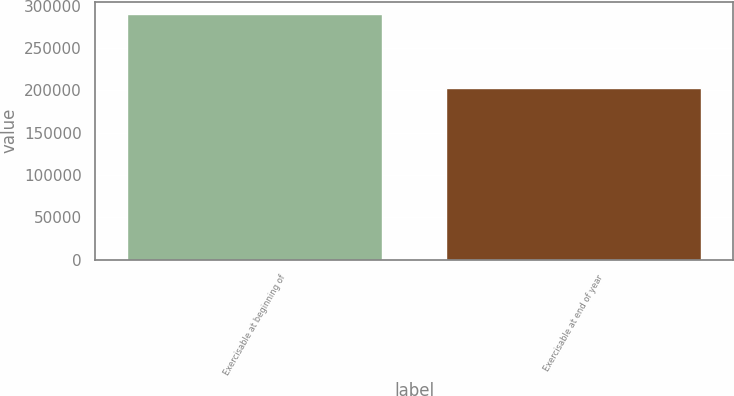<chart> <loc_0><loc_0><loc_500><loc_500><bar_chart><fcel>Exercisable at beginning of<fcel>Exercisable at end of year<nl><fcel>289790<fcel>202275<nl></chart> 